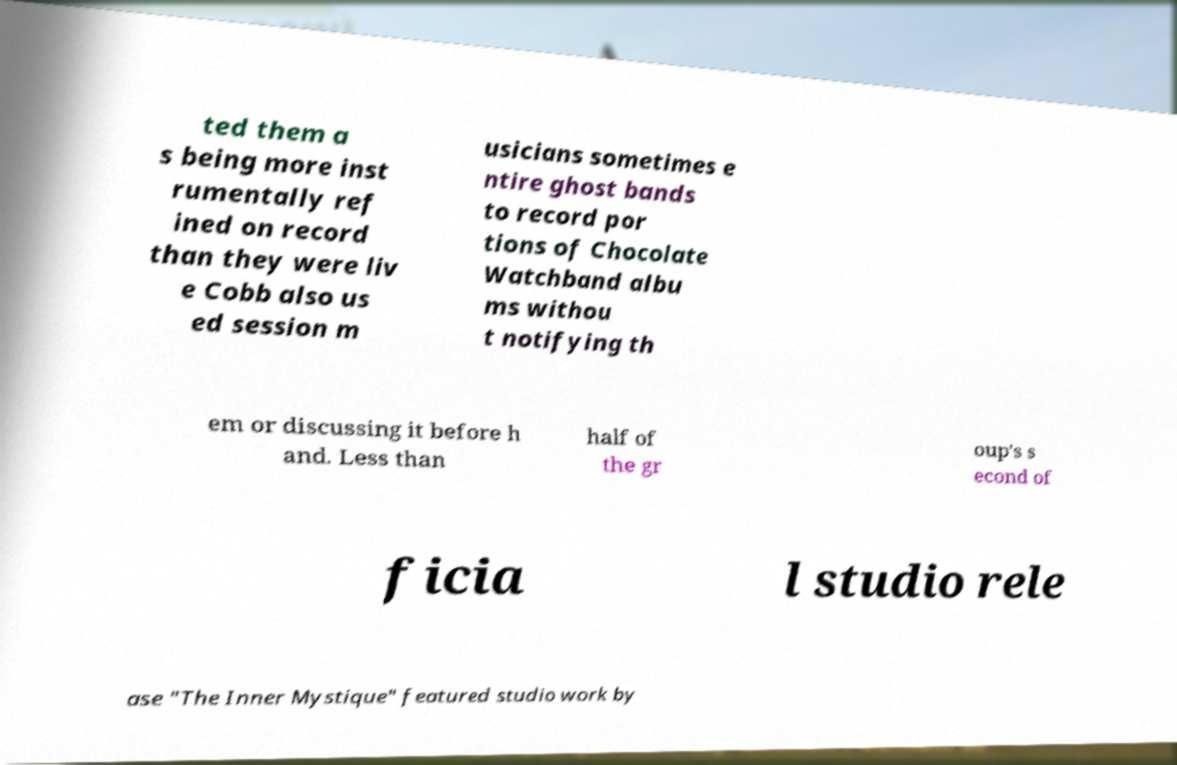Can you accurately transcribe the text from the provided image for me? ted them a s being more inst rumentally ref ined on record than they were liv e Cobb also us ed session m usicians sometimes e ntire ghost bands to record por tions of Chocolate Watchband albu ms withou t notifying th em or discussing it before h and. Less than half of the gr oup's s econd of ficia l studio rele ase "The Inner Mystique" featured studio work by 